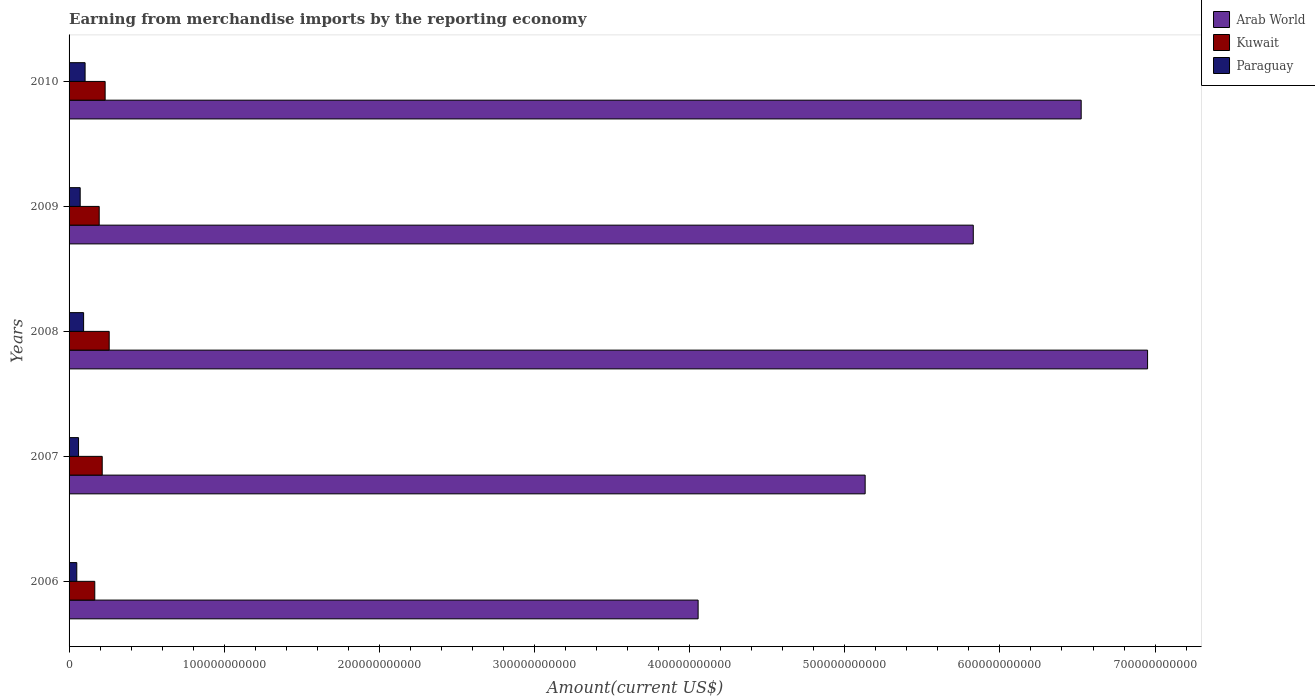How many different coloured bars are there?
Provide a short and direct response. 3. Are the number of bars on each tick of the Y-axis equal?
Provide a short and direct response. Yes. How many bars are there on the 4th tick from the top?
Provide a succinct answer. 3. What is the amount earned from merchandise imports in Arab World in 2008?
Make the answer very short. 6.95e+11. Across all years, what is the maximum amount earned from merchandise imports in Kuwait?
Your answer should be very brief. 2.59e+1. Across all years, what is the minimum amount earned from merchandise imports in Paraguay?
Your answer should be very brief. 4.97e+09. In which year was the amount earned from merchandise imports in Arab World maximum?
Provide a succinct answer. 2008. In which year was the amount earned from merchandise imports in Paraguay minimum?
Your answer should be very brief. 2006. What is the total amount earned from merchandise imports in Paraguay in the graph?
Your response must be concise. 3.79e+1. What is the difference between the amount earned from merchandise imports in Paraguay in 2009 and that in 2010?
Provide a short and direct response. -3.17e+09. What is the difference between the amount earned from merchandise imports in Kuwait in 2010 and the amount earned from merchandise imports in Arab World in 2008?
Keep it short and to the point. -6.72e+11. What is the average amount earned from merchandise imports in Arab World per year?
Give a very brief answer. 5.70e+11. In the year 2010, what is the difference between the amount earned from merchandise imports in Paraguay and amount earned from merchandise imports in Kuwait?
Your response must be concise. -1.29e+1. In how many years, is the amount earned from merchandise imports in Paraguay greater than 260000000000 US$?
Your answer should be compact. 0. What is the ratio of the amount earned from merchandise imports in Paraguay in 2008 to that in 2009?
Your answer should be very brief. 1.31. Is the difference between the amount earned from merchandise imports in Paraguay in 2006 and 2010 greater than the difference between the amount earned from merchandise imports in Kuwait in 2006 and 2010?
Make the answer very short. Yes. What is the difference between the highest and the second highest amount earned from merchandise imports in Arab World?
Offer a very short reply. 4.28e+1. What is the difference between the highest and the lowest amount earned from merchandise imports in Kuwait?
Offer a very short reply. 9.29e+09. In how many years, is the amount earned from merchandise imports in Arab World greater than the average amount earned from merchandise imports in Arab World taken over all years?
Your answer should be compact. 3. Is the sum of the amount earned from merchandise imports in Arab World in 2006 and 2008 greater than the maximum amount earned from merchandise imports in Paraguay across all years?
Offer a terse response. Yes. What does the 1st bar from the top in 2009 represents?
Your answer should be very brief. Paraguay. What does the 3rd bar from the bottom in 2009 represents?
Provide a succinct answer. Paraguay. Is it the case that in every year, the sum of the amount earned from merchandise imports in Kuwait and amount earned from merchandise imports in Arab World is greater than the amount earned from merchandise imports in Paraguay?
Make the answer very short. Yes. How many years are there in the graph?
Make the answer very short. 5. What is the difference between two consecutive major ticks on the X-axis?
Give a very brief answer. 1.00e+11. Does the graph contain any zero values?
Keep it short and to the point. No. Does the graph contain grids?
Offer a very short reply. No. How many legend labels are there?
Your response must be concise. 3. How are the legend labels stacked?
Ensure brevity in your answer.  Vertical. What is the title of the graph?
Make the answer very short. Earning from merchandise imports by the reporting economy. What is the label or title of the X-axis?
Give a very brief answer. Amount(current US$). What is the Amount(current US$) in Arab World in 2006?
Provide a succinct answer. 4.05e+11. What is the Amount(current US$) in Kuwait in 2006?
Offer a very short reply. 1.66e+1. What is the Amount(current US$) of Paraguay in 2006?
Your response must be concise. 4.97e+09. What is the Amount(current US$) in Arab World in 2007?
Your response must be concise. 5.13e+11. What is the Amount(current US$) in Kuwait in 2007?
Keep it short and to the point. 2.14e+1. What is the Amount(current US$) of Paraguay in 2007?
Your answer should be compact. 6.11e+09. What is the Amount(current US$) in Arab World in 2008?
Ensure brevity in your answer.  6.95e+11. What is the Amount(current US$) in Kuwait in 2008?
Your answer should be compact. 2.59e+1. What is the Amount(current US$) in Paraguay in 2008?
Make the answer very short. 9.37e+09. What is the Amount(current US$) in Arab World in 2009?
Offer a very short reply. 5.83e+11. What is the Amount(current US$) in Kuwait in 2009?
Your answer should be compact. 1.94e+1. What is the Amount(current US$) of Paraguay in 2009?
Give a very brief answer. 7.17e+09. What is the Amount(current US$) of Arab World in 2010?
Your response must be concise. 6.52e+11. What is the Amount(current US$) of Kuwait in 2010?
Offer a very short reply. 2.32e+1. What is the Amount(current US$) in Paraguay in 2010?
Ensure brevity in your answer.  1.03e+1. Across all years, what is the maximum Amount(current US$) of Arab World?
Your response must be concise. 6.95e+11. Across all years, what is the maximum Amount(current US$) of Kuwait?
Ensure brevity in your answer.  2.59e+1. Across all years, what is the maximum Amount(current US$) of Paraguay?
Ensure brevity in your answer.  1.03e+1. Across all years, what is the minimum Amount(current US$) of Arab World?
Offer a terse response. 4.05e+11. Across all years, what is the minimum Amount(current US$) of Kuwait?
Your response must be concise. 1.66e+1. Across all years, what is the minimum Amount(current US$) in Paraguay?
Provide a short and direct response. 4.97e+09. What is the total Amount(current US$) of Arab World in the graph?
Your response must be concise. 2.85e+12. What is the total Amount(current US$) in Kuwait in the graph?
Your answer should be very brief. 1.06e+11. What is the total Amount(current US$) of Paraguay in the graph?
Keep it short and to the point. 3.79e+1. What is the difference between the Amount(current US$) of Arab World in 2006 and that in 2007?
Ensure brevity in your answer.  -1.08e+11. What is the difference between the Amount(current US$) in Kuwait in 2006 and that in 2007?
Ensure brevity in your answer.  -4.80e+09. What is the difference between the Amount(current US$) of Paraguay in 2006 and that in 2007?
Your answer should be very brief. -1.14e+09. What is the difference between the Amount(current US$) in Arab World in 2006 and that in 2008?
Ensure brevity in your answer.  -2.90e+11. What is the difference between the Amount(current US$) of Kuwait in 2006 and that in 2008?
Provide a short and direct response. -9.29e+09. What is the difference between the Amount(current US$) in Paraguay in 2006 and that in 2008?
Make the answer very short. -4.40e+09. What is the difference between the Amount(current US$) in Arab World in 2006 and that in 2009?
Provide a succinct answer. -1.77e+11. What is the difference between the Amount(current US$) in Kuwait in 2006 and that in 2009?
Your answer should be compact. -2.85e+09. What is the difference between the Amount(current US$) of Paraguay in 2006 and that in 2009?
Keep it short and to the point. -2.20e+09. What is the difference between the Amount(current US$) in Arab World in 2006 and that in 2010?
Provide a succinct answer. -2.47e+11. What is the difference between the Amount(current US$) of Kuwait in 2006 and that in 2010?
Give a very brief answer. -6.68e+09. What is the difference between the Amount(current US$) of Paraguay in 2006 and that in 2010?
Provide a succinct answer. -5.36e+09. What is the difference between the Amount(current US$) of Arab World in 2007 and that in 2008?
Ensure brevity in your answer.  -1.82e+11. What is the difference between the Amount(current US$) in Kuwait in 2007 and that in 2008?
Your answer should be compact. -4.50e+09. What is the difference between the Amount(current US$) of Paraguay in 2007 and that in 2008?
Keep it short and to the point. -3.27e+09. What is the difference between the Amount(current US$) of Arab World in 2007 and that in 2009?
Your response must be concise. -6.97e+1. What is the difference between the Amount(current US$) in Kuwait in 2007 and that in 2009?
Provide a succinct answer. 1.94e+09. What is the difference between the Amount(current US$) in Paraguay in 2007 and that in 2009?
Your answer should be compact. -1.06e+09. What is the difference between the Amount(current US$) in Arab World in 2007 and that in 2010?
Your answer should be very brief. -1.39e+11. What is the difference between the Amount(current US$) of Kuwait in 2007 and that in 2010?
Keep it short and to the point. -1.88e+09. What is the difference between the Amount(current US$) in Paraguay in 2007 and that in 2010?
Offer a very short reply. -4.23e+09. What is the difference between the Amount(current US$) in Arab World in 2008 and that in 2009?
Offer a very short reply. 1.12e+11. What is the difference between the Amount(current US$) in Kuwait in 2008 and that in 2009?
Your answer should be very brief. 6.44e+09. What is the difference between the Amount(current US$) of Paraguay in 2008 and that in 2009?
Keep it short and to the point. 2.20e+09. What is the difference between the Amount(current US$) of Arab World in 2008 and that in 2010?
Offer a very short reply. 4.28e+1. What is the difference between the Amount(current US$) of Kuwait in 2008 and that in 2010?
Offer a terse response. 2.62e+09. What is the difference between the Amount(current US$) in Paraguay in 2008 and that in 2010?
Provide a succinct answer. -9.60e+08. What is the difference between the Amount(current US$) in Arab World in 2009 and that in 2010?
Your answer should be compact. -6.95e+1. What is the difference between the Amount(current US$) in Kuwait in 2009 and that in 2010?
Make the answer very short. -3.82e+09. What is the difference between the Amount(current US$) of Paraguay in 2009 and that in 2010?
Give a very brief answer. -3.17e+09. What is the difference between the Amount(current US$) in Arab World in 2006 and the Amount(current US$) in Kuwait in 2007?
Make the answer very short. 3.84e+11. What is the difference between the Amount(current US$) of Arab World in 2006 and the Amount(current US$) of Paraguay in 2007?
Offer a very short reply. 3.99e+11. What is the difference between the Amount(current US$) in Kuwait in 2006 and the Amount(current US$) in Paraguay in 2007?
Your answer should be compact. 1.05e+1. What is the difference between the Amount(current US$) of Arab World in 2006 and the Amount(current US$) of Kuwait in 2008?
Make the answer very short. 3.80e+11. What is the difference between the Amount(current US$) in Arab World in 2006 and the Amount(current US$) in Paraguay in 2008?
Keep it short and to the point. 3.96e+11. What is the difference between the Amount(current US$) of Kuwait in 2006 and the Amount(current US$) of Paraguay in 2008?
Make the answer very short. 7.20e+09. What is the difference between the Amount(current US$) of Arab World in 2006 and the Amount(current US$) of Kuwait in 2009?
Your answer should be very brief. 3.86e+11. What is the difference between the Amount(current US$) of Arab World in 2006 and the Amount(current US$) of Paraguay in 2009?
Offer a terse response. 3.98e+11. What is the difference between the Amount(current US$) of Kuwait in 2006 and the Amount(current US$) of Paraguay in 2009?
Keep it short and to the point. 9.40e+09. What is the difference between the Amount(current US$) of Arab World in 2006 and the Amount(current US$) of Kuwait in 2010?
Give a very brief answer. 3.82e+11. What is the difference between the Amount(current US$) of Arab World in 2006 and the Amount(current US$) of Paraguay in 2010?
Your answer should be very brief. 3.95e+11. What is the difference between the Amount(current US$) in Kuwait in 2006 and the Amount(current US$) in Paraguay in 2010?
Your answer should be very brief. 6.24e+09. What is the difference between the Amount(current US$) of Arab World in 2007 and the Amount(current US$) of Kuwait in 2008?
Your response must be concise. 4.87e+11. What is the difference between the Amount(current US$) of Arab World in 2007 and the Amount(current US$) of Paraguay in 2008?
Your answer should be very brief. 5.04e+11. What is the difference between the Amount(current US$) in Kuwait in 2007 and the Amount(current US$) in Paraguay in 2008?
Ensure brevity in your answer.  1.20e+1. What is the difference between the Amount(current US$) in Arab World in 2007 and the Amount(current US$) in Kuwait in 2009?
Provide a short and direct response. 4.94e+11. What is the difference between the Amount(current US$) in Arab World in 2007 and the Amount(current US$) in Paraguay in 2009?
Provide a succinct answer. 5.06e+11. What is the difference between the Amount(current US$) of Kuwait in 2007 and the Amount(current US$) of Paraguay in 2009?
Your answer should be compact. 1.42e+1. What is the difference between the Amount(current US$) of Arab World in 2007 and the Amount(current US$) of Kuwait in 2010?
Your response must be concise. 4.90e+11. What is the difference between the Amount(current US$) of Arab World in 2007 and the Amount(current US$) of Paraguay in 2010?
Provide a short and direct response. 5.03e+11. What is the difference between the Amount(current US$) in Kuwait in 2007 and the Amount(current US$) in Paraguay in 2010?
Keep it short and to the point. 1.10e+1. What is the difference between the Amount(current US$) in Arab World in 2008 and the Amount(current US$) in Kuwait in 2009?
Your answer should be compact. 6.76e+11. What is the difference between the Amount(current US$) in Arab World in 2008 and the Amount(current US$) in Paraguay in 2009?
Offer a terse response. 6.88e+11. What is the difference between the Amount(current US$) of Kuwait in 2008 and the Amount(current US$) of Paraguay in 2009?
Offer a very short reply. 1.87e+1. What is the difference between the Amount(current US$) in Arab World in 2008 and the Amount(current US$) in Kuwait in 2010?
Provide a succinct answer. 6.72e+11. What is the difference between the Amount(current US$) in Arab World in 2008 and the Amount(current US$) in Paraguay in 2010?
Give a very brief answer. 6.85e+11. What is the difference between the Amount(current US$) in Kuwait in 2008 and the Amount(current US$) in Paraguay in 2010?
Your answer should be very brief. 1.55e+1. What is the difference between the Amount(current US$) in Arab World in 2009 and the Amount(current US$) in Kuwait in 2010?
Your response must be concise. 5.60e+11. What is the difference between the Amount(current US$) in Arab World in 2009 and the Amount(current US$) in Paraguay in 2010?
Your response must be concise. 5.72e+11. What is the difference between the Amount(current US$) in Kuwait in 2009 and the Amount(current US$) in Paraguay in 2010?
Provide a succinct answer. 9.09e+09. What is the average Amount(current US$) of Arab World per year?
Give a very brief answer. 5.70e+11. What is the average Amount(current US$) in Kuwait per year?
Ensure brevity in your answer.  2.13e+1. What is the average Amount(current US$) in Paraguay per year?
Your answer should be very brief. 7.59e+09. In the year 2006, what is the difference between the Amount(current US$) in Arab World and Amount(current US$) in Kuwait?
Your response must be concise. 3.89e+11. In the year 2006, what is the difference between the Amount(current US$) in Arab World and Amount(current US$) in Paraguay?
Your answer should be very brief. 4.01e+11. In the year 2006, what is the difference between the Amount(current US$) of Kuwait and Amount(current US$) of Paraguay?
Your answer should be compact. 1.16e+1. In the year 2007, what is the difference between the Amount(current US$) in Arab World and Amount(current US$) in Kuwait?
Provide a succinct answer. 4.92e+11. In the year 2007, what is the difference between the Amount(current US$) in Arab World and Amount(current US$) in Paraguay?
Keep it short and to the point. 5.07e+11. In the year 2007, what is the difference between the Amount(current US$) in Kuwait and Amount(current US$) in Paraguay?
Your answer should be very brief. 1.53e+1. In the year 2008, what is the difference between the Amount(current US$) in Arab World and Amount(current US$) in Kuwait?
Provide a succinct answer. 6.69e+11. In the year 2008, what is the difference between the Amount(current US$) of Arab World and Amount(current US$) of Paraguay?
Make the answer very short. 6.86e+11. In the year 2008, what is the difference between the Amount(current US$) of Kuwait and Amount(current US$) of Paraguay?
Give a very brief answer. 1.65e+1. In the year 2009, what is the difference between the Amount(current US$) in Arab World and Amount(current US$) in Kuwait?
Your response must be concise. 5.63e+11. In the year 2009, what is the difference between the Amount(current US$) of Arab World and Amount(current US$) of Paraguay?
Ensure brevity in your answer.  5.76e+11. In the year 2009, what is the difference between the Amount(current US$) of Kuwait and Amount(current US$) of Paraguay?
Your answer should be compact. 1.23e+1. In the year 2010, what is the difference between the Amount(current US$) in Arab World and Amount(current US$) in Kuwait?
Offer a very short reply. 6.29e+11. In the year 2010, what is the difference between the Amount(current US$) in Arab World and Amount(current US$) in Paraguay?
Your answer should be compact. 6.42e+11. In the year 2010, what is the difference between the Amount(current US$) of Kuwait and Amount(current US$) of Paraguay?
Your response must be concise. 1.29e+1. What is the ratio of the Amount(current US$) in Arab World in 2006 to that in 2007?
Your response must be concise. 0.79. What is the ratio of the Amount(current US$) of Kuwait in 2006 to that in 2007?
Provide a short and direct response. 0.78. What is the ratio of the Amount(current US$) in Paraguay in 2006 to that in 2007?
Give a very brief answer. 0.81. What is the ratio of the Amount(current US$) of Arab World in 2006 to that in 2008?
Your answer should be compact. 0.58. What is the ratio of the Amount(current US$) of Kuwait in 2006 to that in 2008?
Make the answer very short. 0.64. What is the ratio of the Amount(current US$) in Paraguay in 2006 to that in 2008?
Your answer should be very brief. 0.53. What is the ratio of the Amount(current US$) in Arab World in 2006 to that in 2009?
Make the answer very short. 0.7. What is the ratio of the Amount(current US$) of Kuwait in 2006 to that in 2009?
Your answer should be very brief. 0.85. What is the ratio of the Amount(current US$) in Paraguay in 2006 to that in 2009?
Your answer should be compact. 0.69. What is the ratio of the Amount(current US$) in Arab World in 2006 to that in 2010?
Your answer should be very brief. 0.62. What is the ratio of the Amount(current US$) in Kuwait in 2006 to that in 2010?
Provide a short and direct response. 0.71. What is the ratio of the Amount(current US$) in Paraguay in 2006 to that in 2010?
Your response must be concise. 0.48. What is the ratio of the Amount(current US$) in Arab World in 2007 to that in 2008?
Your answer should be compact. 0.74. What is the ratio of the Amount(current US$) in Kuwait in 2007 to that in 2008?
Your response must be concise. 0.83. What is the ratio of the Amount(current US$) of Paraguay in 2007 to that in 2008?
Offer a terse response. 0.65. What is the ratio of the Amount(current US$) in Arab World in 2007 to that in 2009?
Provide a succinct answer. 0.88. What is the ratio of the Amount(current US$) in Paraguay in 2007 to that in 2009?
Your answer should be very brief. 0.85. What is the ratio of the Amount(current US$) of Arab World in 2007 to that in 2010?
Ensure brevity in your answer.  0.79. What is the ratio of the Amount(current US$) of Kuwait in 2007 to that in 2010?
Offer a very short reply. 0.92. What is the ratio of the Amount(current US$) in Paraguay in 2007 to that in 2010?
Give a very brief answer. 0.59. What is the ratio of the Amount(current US$) in Arab World in 2008 to that in 2009?
Your answer should be very brief. 1.19. What is the ratio of the Amount(current US$) in Kuwait in 2008 to that in 2009?
Your answer should be very brief. 1.33. What is the ratio of the Amount(current US$) in Paraguay in 2008 to that in 2009?
Ensure brevity in your answer.  1.31. What is the ratio of the Amount(current US$) in Arab World in 2008 to that in 2010?
Provide a succinct answer. 1.07. What is the ratio of the Amount(current US$) in Kuwait in 2008 to that in 2010?
Offer a very short reply. 1.11. What is the ratio of the Amount(current US$) in Paraguay in 2008 to that in 2010?
Provide a short and direct response. 0.91. What is the ratio of the Amount(current US$) of Arab World in 2009 to that in 2010?
Offer a terse response. 0.89. What is the ratio of the Amount(current US$) in Kuwait in 2009 to that in 2010?
Give a very brief answer. 0.84. What is the ratio of the Amount(current US$) in Paraguay in 2009 to that in 2010?
Your answer should be very brief. 0.69. What is the difference between the highest and the second highest Amount(current US$) of Arab World?
Make the answer very short. 4.28e+1. What is the difference between the highest and the second highest Amount(current US$) of Kuwait?
Provide a succinct answer. 2.62e+09. What is the difference between the highest and the second highest Amount(current US$) of Paraguay?
Ensure brevity in your answer.  9.60e+08. What is the difference between the highest and the lowest Amount(current US$) of Arab World?
Provide a short and direct response. 2.90e+11. What is the difference between the highest and the lowest Amount(current US$) in Kuwait?
Provide a succinct answer. 9.29e+09. What is the difference between the highest and the lowest Amount(current US$) of Paraguay?
Your response must be concise. 5.36e+09. 